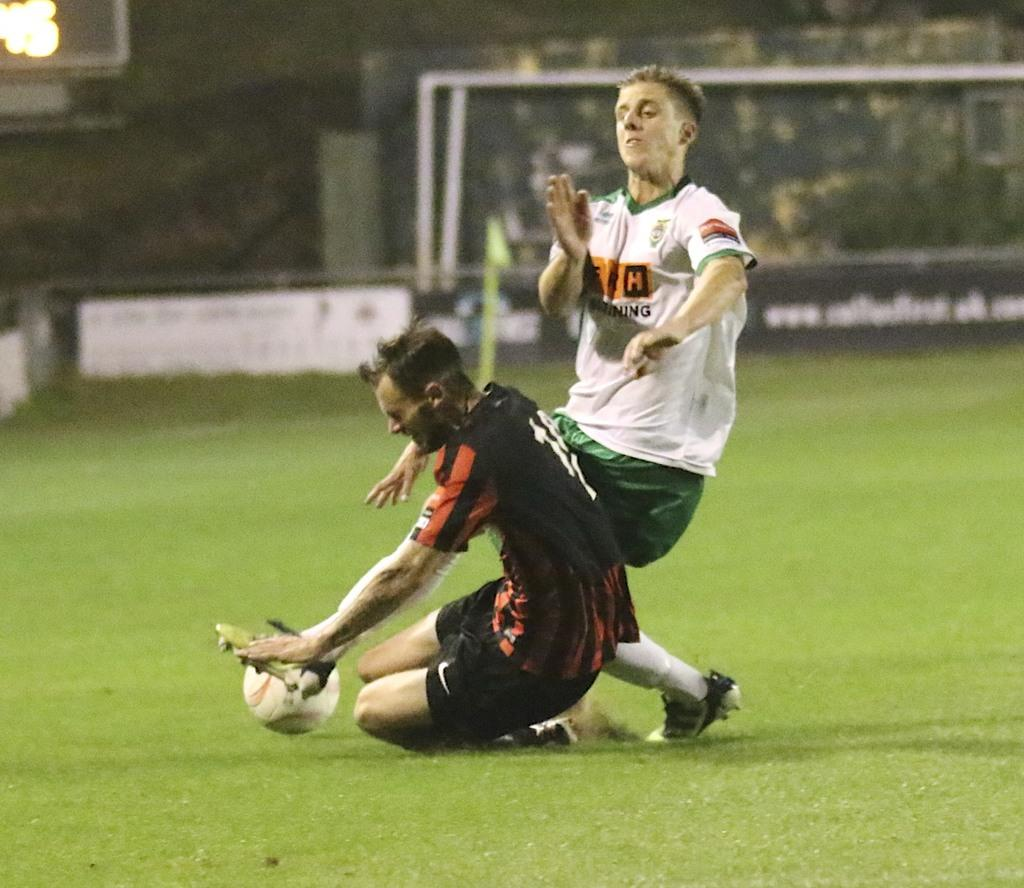What is the color of the grass in the image? The grass in the image is green. How many people are in the image? There are two persons in the image. What are the two persons doing in the image? The two persons are playing a game. What object is associated with the game they are playing? There is a football visible in the image. What type of art can be seen on the mailbox in the image? There is no mailbox present in the image, so it is not possible to determine what type of art might be on it. 